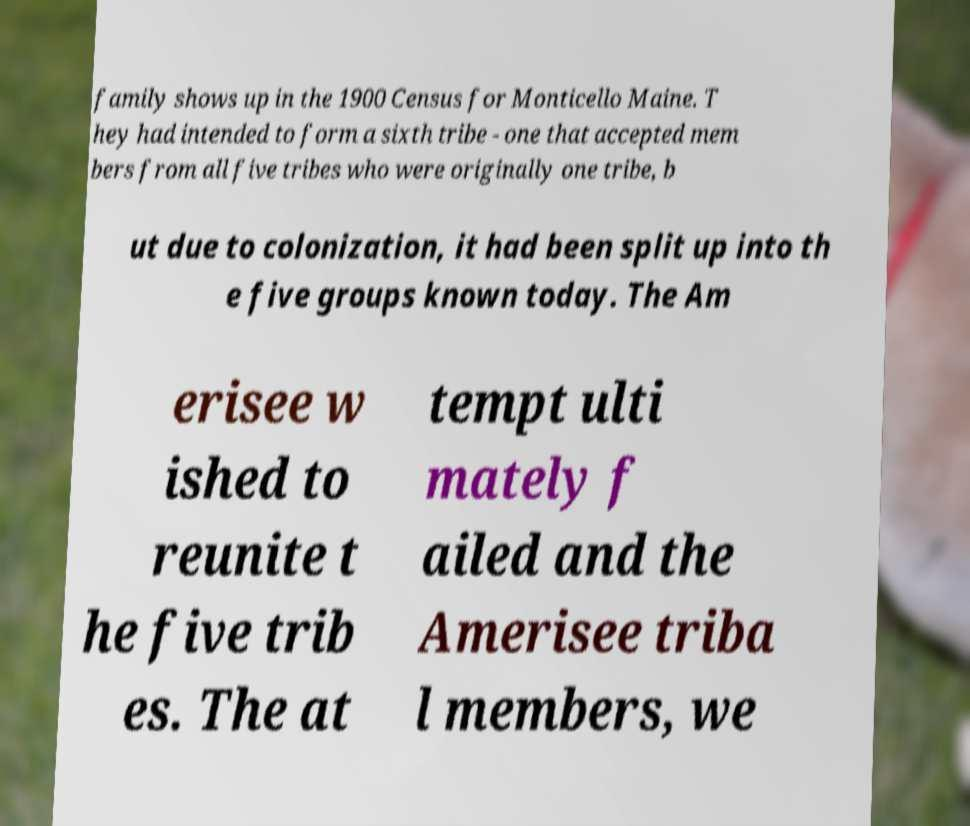Can you accurately transcribe the text from the provided image for me? family shows up in the 1900 Census for Monticello Maine. T hey had intended to form a sixth tribe - one that accepted mem bers from all five tribes who were originally one tribe, b ut due to colonization, it had been split up into th e five groups known today. The Am erisee w ished to reunite t he five trib es. The at tempt ulti mately f ailed and the Amerisee triba l members, we 